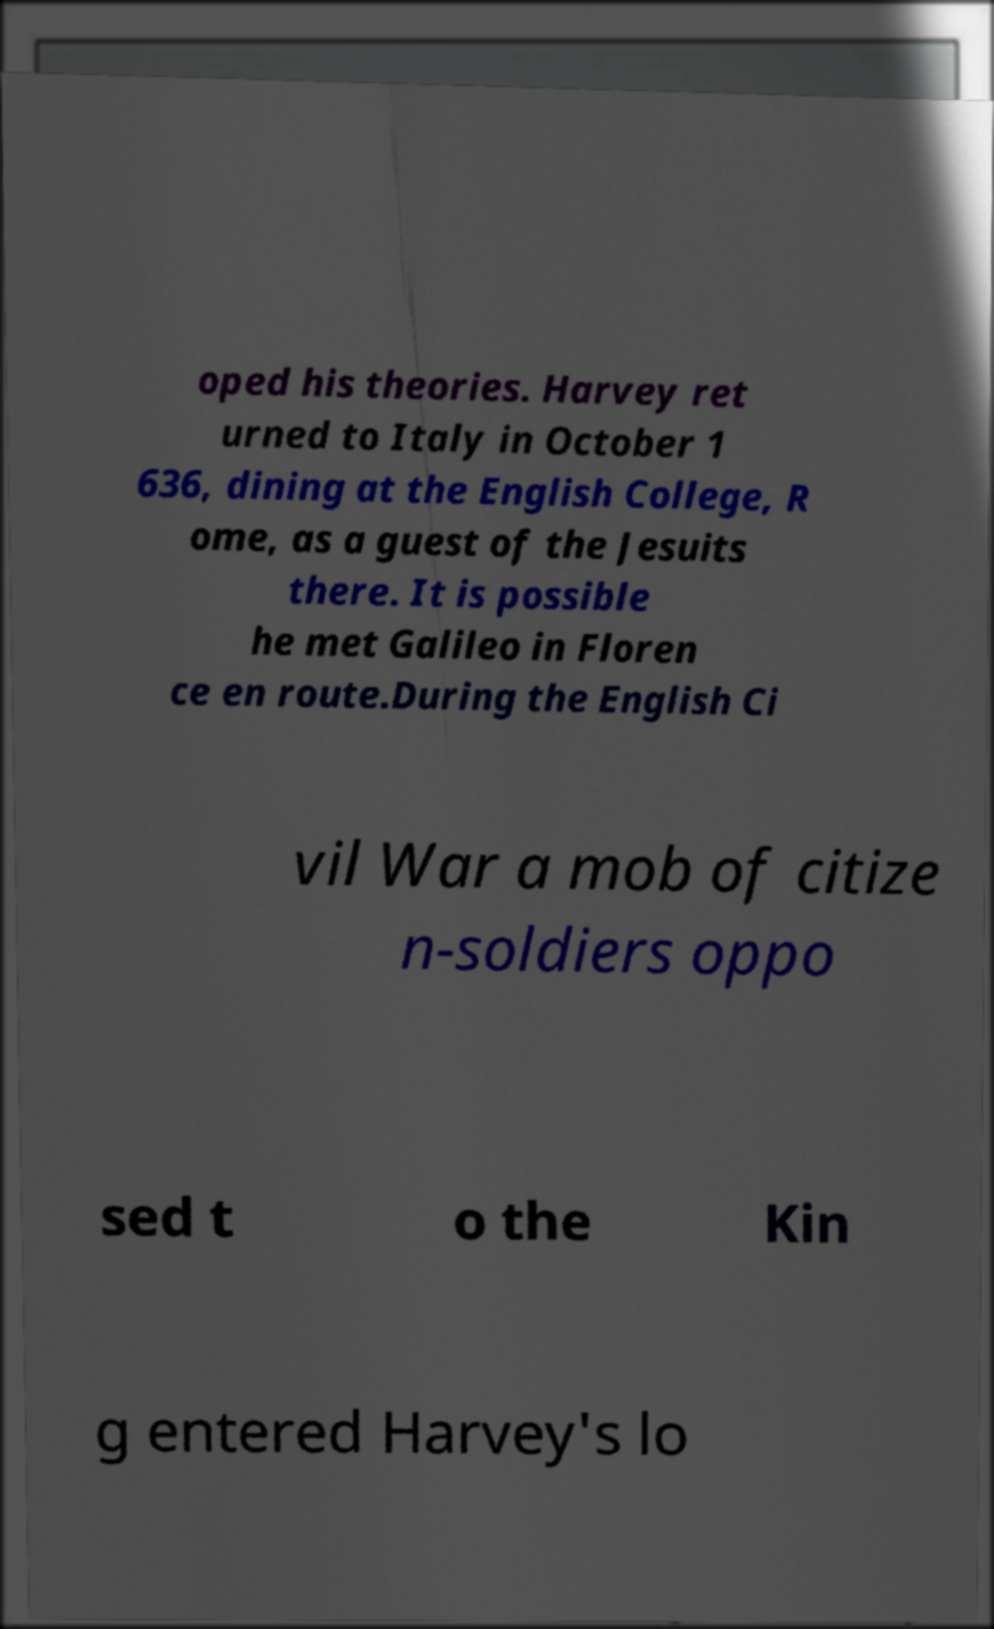Could you assist in decoding the text presented in this image and type it out clearly? oped his theories. Harvey ret urned to Italy in October 1 636, dining at the English College, R ome, as a guest of the Jesuits there. It is possible he met Galileo in Floren ce en route.During the English Ci vil War a mob of citize n-soldiers oppo sed t o the Kin g entered Harvey's lo 